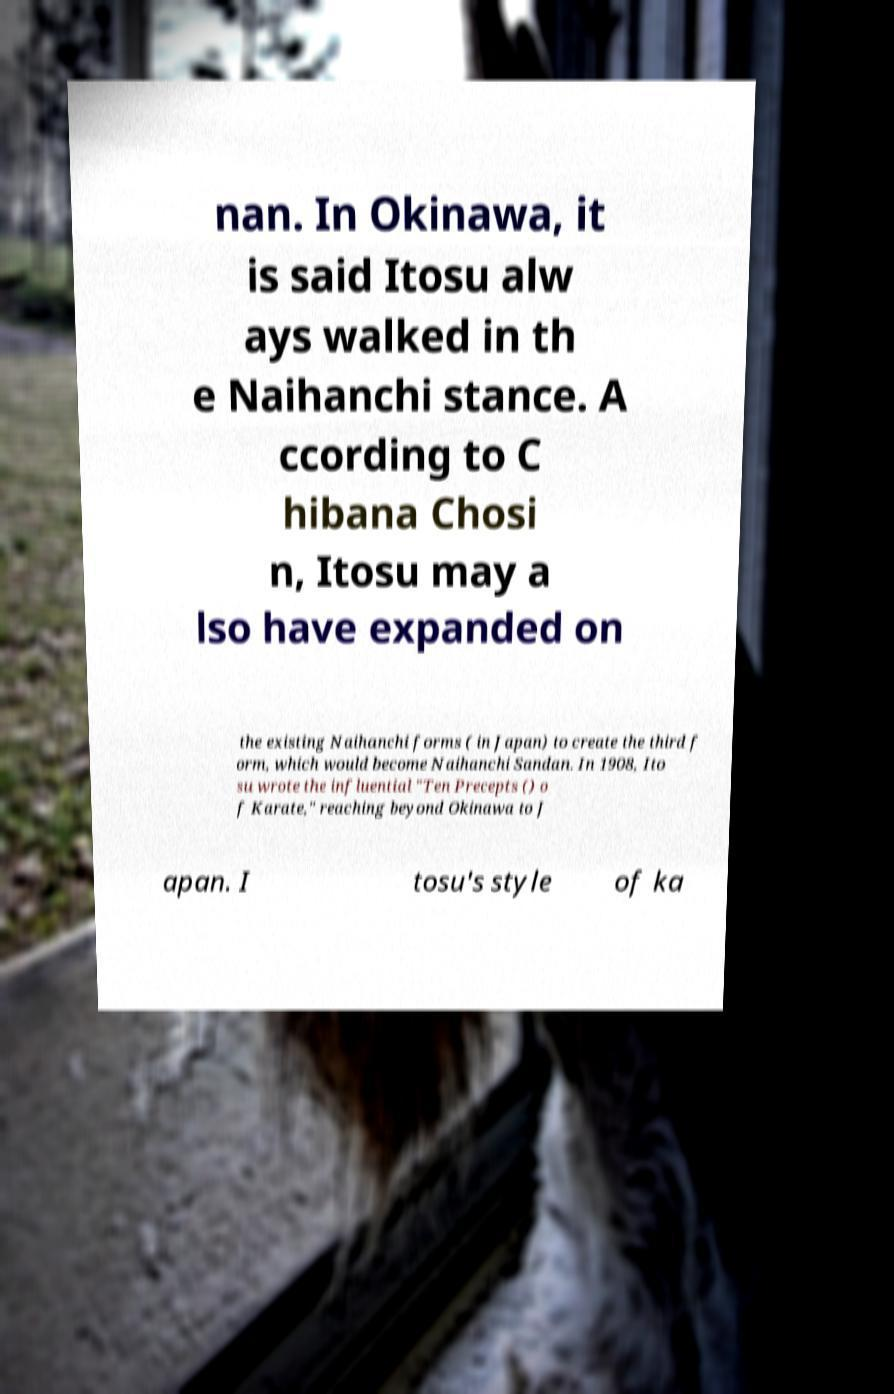Could you assist in decoding the text presented in this image and type it out clearly? nan. In Okinawa, it is said Itosu alw ays walked in th e Naihanchi stance. A ccording to C hibana Chosi n, Itosu may a lso have expanded on the existing Naihanchi forms ( in Japan) to create the third f orm, which would become Naihanchi Sandan. In 1908, Ito su wrote the influential "Ten Precepts () o f Karate," reaching beyond Okinawa to J apan. I tosu's style of ka 